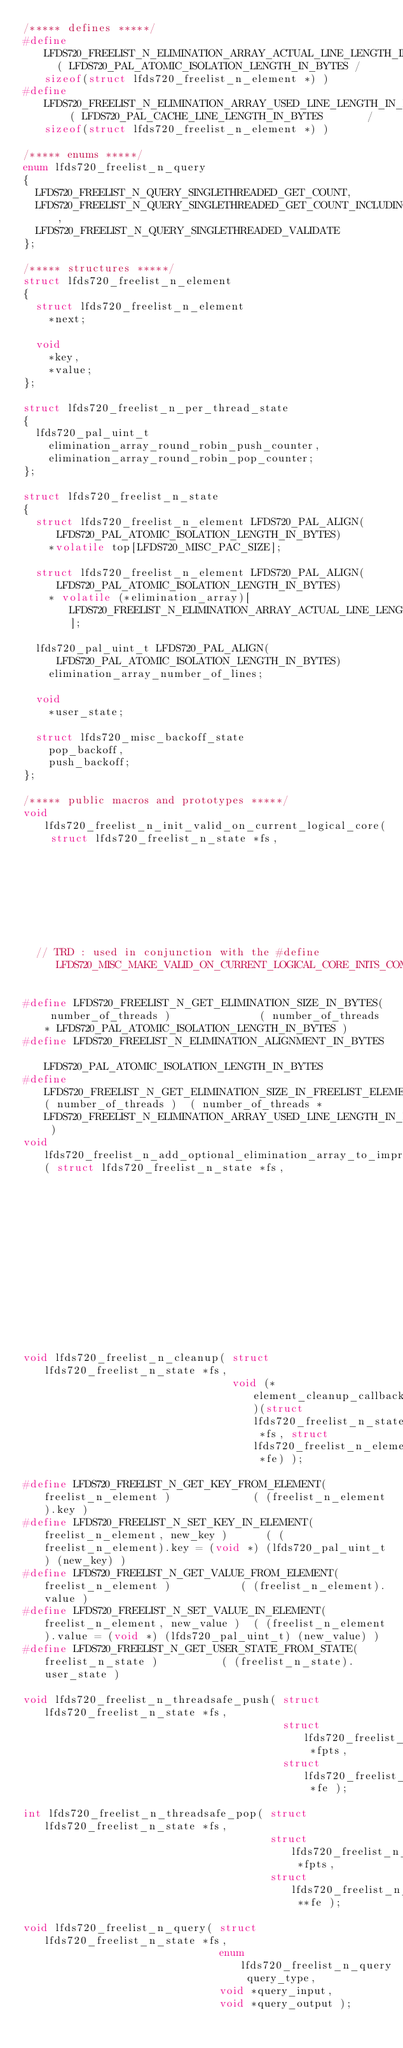Convert code to text. <code><loc_0><loc_0><loc_500><loc_500><_C_>/***** defines *****/
#define LFDS720_FREELIST_N_ELIMINATION_ARRAY_ACTUAL_LINE_LENGTH_IN_FREELIST_N_POINTER_ELEMENTS  ( LFDS720_PAL_ATOMIC_ISOLATION_LENGTH_IN_BYTES / sizeof(struct lfds720_freelist_n_element *) )
#define LFDS720_FREELIST_N_ELIMINATION_ARRAY_USED_LINE_LENGTH_IN_FREELIST_N_POINTER_ELEMENTS    ( LFDS720_PAL_CACHE_LINE_LENGTH_IN_BYTES       / sizeof(struct lfds720_freelist_n_element *) )

/***** enums *****/
enum lfds720_freelist_n_query
{
  LFDS720_FREELIST_N_QUERY_SINGLETHREADED_GET_COUNT,
  LFDS720_FREELIST_N_QUERY_SINGLETHREADED_GET_COUNT_INCLUDING_ELIMINATION_ARRAY,
  LFDS720_FREELIST_N_QUERY_SINGLETHREADED_VALIDATE
};

/***** structures *****/
struct lfds720_freelist_n_element
{
  struct lfds720_freelist_n_element
    *next;

  void
    *key,
    *value;
};

struct lfds720_freelist_n_per_thread_state
{
  lfds720_pal_uint_t
    elimination_array_round_robin_push_counter,
    elimination_array_round_robin_pop_counter;
};

struct lfds720_freelist_n_state
{
  struct lfds720_freelist_n_element LFDS720_PAL_ALIGN(LFDS720_PAL_ATOMIC_ISOLATION_LENGTH_IN_BYTES)
    *volatile top[LFDS720_MISC_PAC_SIZE];

  struct lfds720_freelist_n_element LFDS720_PAL_ALIGN(LFDS720_PAL_ATOMIC_ISOLATION_LENGTH_IN_BYTES)
    * volatile (*elimination_array)[LFDS720_FREELIST_N_ELIMINATION_ARRAY_ACTUAL_LINE_LENGTH_IN_FREELIST_N_POINTER_ELEMENTS];

  lfds720_pal_uint_t LFDS720_PAL_ALIGN(LFDS720_PAL_ATOMIC_ISOLATION_LENGTH_IN_BYTES)
    elimination_array_number_of_lines;

  void
    *user_state;

  struct lfds720_misc_backoff_state
    pop_backoff,
    push_backoff;
};

/***** public macros and prototypes *****/
void lfds720_freelist_n_init_valid_on_current_logical_core( struct lfds720_freelist_n_state *fs,
                                                            void *user_state );
  // TRD : used in conjunction with the #define LFDS720_MISC_MAKE_VALID_ON_CURRENT_LOGICAL_CORE_INITS_COMPLETED_BEFORE_NOW_ON_ANY_OTHER_PHYSICAL_CORE

#define LFDS720_FREELIST_N_GET_ELIMINATION_SIZE_IN_BYTES( number_of_threads )              ( number_of_threads * LFDS720_PAL_ATOMIC_ISOLATION_LENGTH_IN_BYTES )
#define LFDS720_FREELIST_N_ELIMINATION_ALIGNMENT_IN_BYTES                                  LFDS720_PAL_ATOMIC_ISOLATION_LENGTH_IN_BYTES
#define LFDS720_FREELIST_N_GET_ELIMINATION_SIZE_IN_FREELIST_ELEMENTS( number_of_threads )  ( number_of_threads * LFDS720_FREELIST_N_ELIMINATION_ARRAY_USED_LINE_LENGTH_IN_FREELIST_N_POINTER_ELEMENTS )
void lfds720_freelist_n_add_optional_elimination_array_to_improve_performance( struct lfds720_freelist_n_state *fs, 
                                                                               void *elimination_array,
                                                                               size_t elimination_array_size_in_bytes );

void lfds720_freelist_n_cleanup( struct lfds720_freelist_n_state *fs,
                                 void (*element_cleanup_callback)(struct lfds720_freelist_n_state *fs, struct lfds720_freelist_n_element *fe) );

#define LFDS720_FREELIST_N_GET_KEY_FROM_ELEMENT( freelist_n_element )             ( (freelist_n_element).key )
#define LFDS720_FREELIST_N_SET_KEY_IN_ELEMENT( freelist_n_element, new_key )      ( (freelist_n_element).key = (void *) (lfds720_pal_uint_t) (new_key) )
#define LFDS720_FREELIST_N_GET_VALUE_FROM_ELEMENT( freelist_n_element )           ( (freelist_n_element).value )
#define LFDS720_FREELIST_N_SET_VALUE_IN_ELEMENT( freelist_n_element, new_value )  ( (freelist_n_element).value = (void *) (lfds720_pal_uint_t) (new_value) )
#define LFDS720_FREELIST_N_GET_USER_STATE_FROM_STATE( freelist_n_state )          ( (freelist_n_state).user_state )

void lfds720_freelist_n_threadsafe_push( struct lfds720_freelist_n_state *fs,
                                         struct lfds720_freelist_n_per_thread_state *fpts,
                                         struct lfds720_freelist_n_element *fe );

int lfds720_freelist_n_threadsafe_pop( struct lfds720_freelist_n_state *fs,
                                       struct lfds720_freelist_n_per_thread_state *fpts,
                                       struct lfds720_freelist_n_element **fe );

void lfds720_freelist_n_query( struct lfds720_freelist_n_state *fs,
                               enum lfds720_freelist_n_query query_type,
                               void *query_input,
                               void *query_output );


</code> 